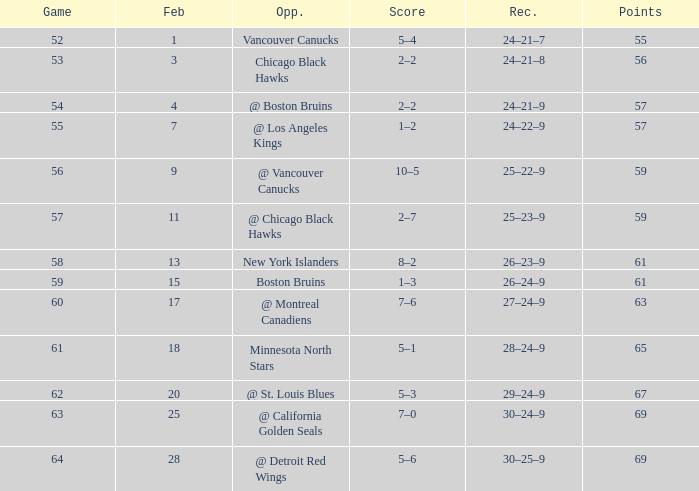How many games have a record of 30–25–9 and more points than 69? 0.0. 